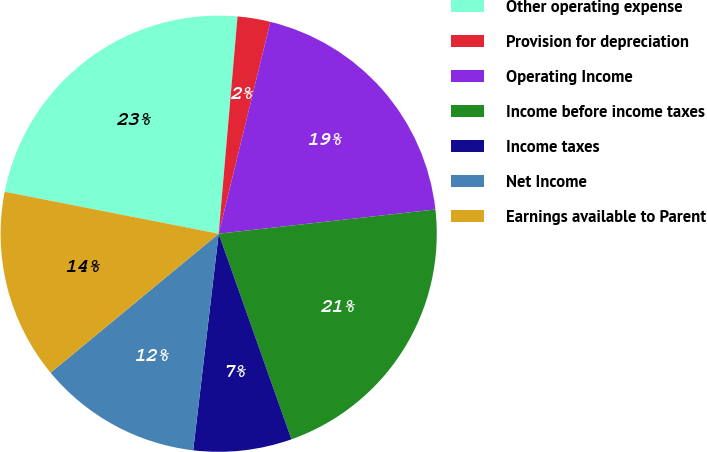Convert chart to OTSL. <chart><loc_0><loc_0><loc_500><loc_500><pie_chart><fcel>Other operating expense<fcel>Provision for depreciation<fcel>Operating Income<fcel>Income before income taxes<fcel>Income taxes<fcel>Net Income<fcel>Earnings available to Parent<nl><fcel>23.3%<fcel>2.43%<fcel>19.42%<fcel>21.36%<fcel>7.28%<fcel>12.14%<fcel>14.08%<nl></chart> 